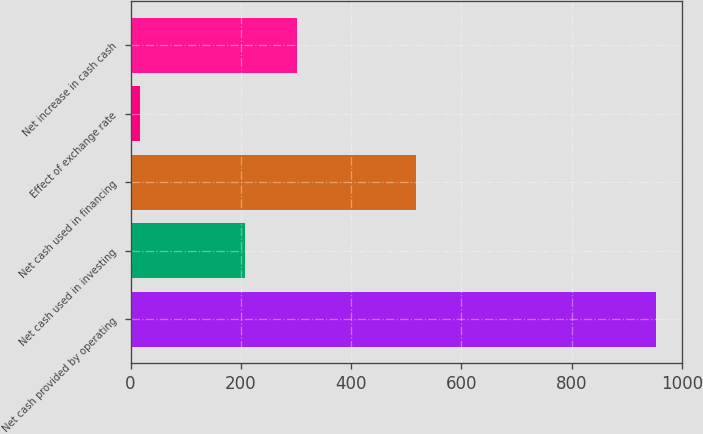<chart> <loc_0><loc_0><loc_500><loc_500><bar_chart><fcel>Net cash provided by operating<fcel>Net cash used in investing<fcel>Net cash used in financing<fcel>Effect of exchange rate<fcel>Net increase in cash cash<nl><fcel>952.6<fcel>208.1<fcel>518.4<fcel>16.4<fcel>301.72<nl></chart> 